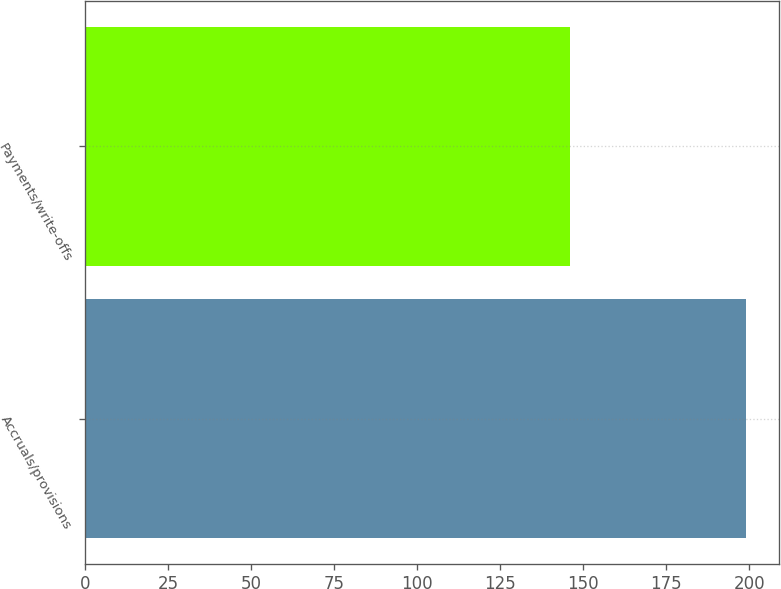Convert chart to OTSL. <chart><loc_0><loc_0><loc_500><loc_500><bar_chart><fcel>Accruals/provisions<fcel>Payments/write-offs<nl><fcel>199<fcel>146<nl></chart> 